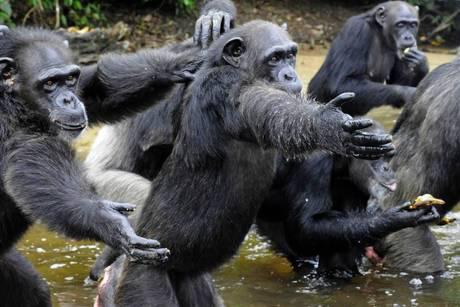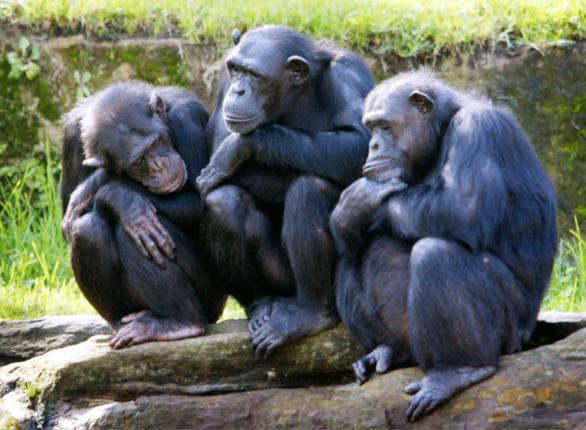The first image is the image on the left, the second image is the image on the right. Assess this claim about the two images: "The right image features three apes side by side, all sitting crouched with bent knees.". Correct or not? Answer yes or no. Yes. The first image is the image on the left, the second image is the image on the right. Considering the images on both sides, is "An image includes at least one chimp sitting behind another chimp and grooming its fur." valid? Answer yes or no. No. The first image is the image on the left, the second image is the image on the right. Assess this claim about the two images: "At least one primate in one of the images is sitting on a branch.". Correct or not? Answer yes or no. Yes. 